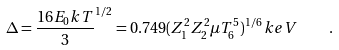<formula> <loc_0><loc_0><loc_500><loc_500>\Delta = \frac { 1 6 E _ { 0 } k T } { 3 } ^ { 1 / 2 } = 0 . 7 4 9 ( Z _ { 1 } ^ { 2 } Z _ { 2 } ^ { 2 } \mu T _ { 6 } ^ { 5 } ) ^ { 1 / 6 } \, k e V \quad .</formula> 